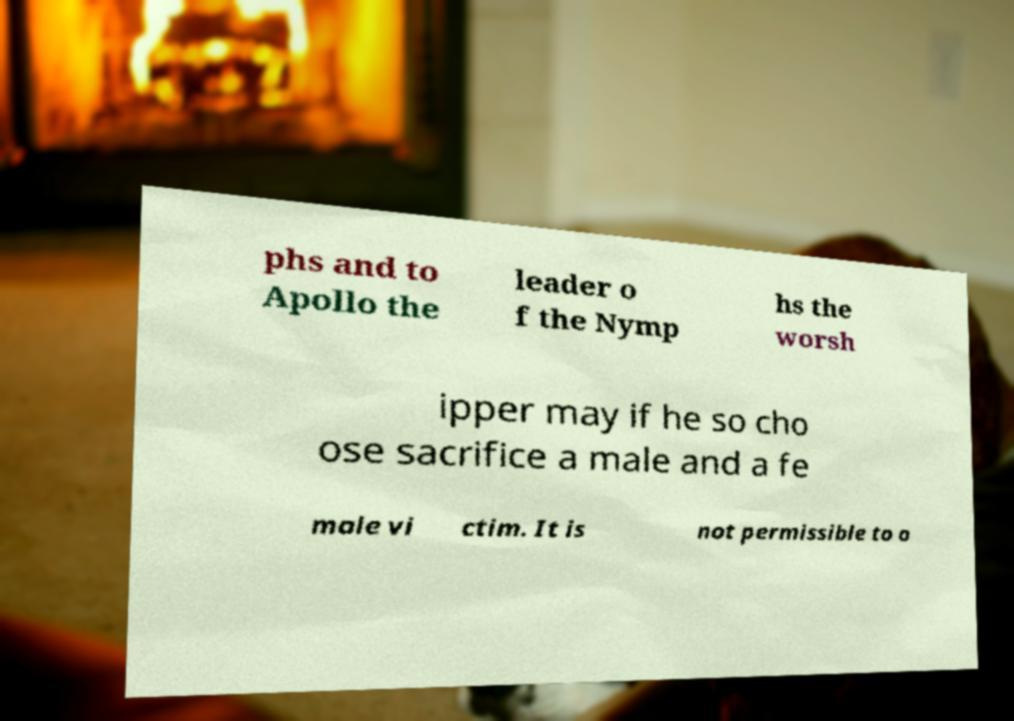Could you assist in decoding the text presented in this image and type it out clearly? phs and to Apollo the leader o f the Nymp hs the worsh ipper may if he so cho ose sacrifice a male and a fe male vi ctim. It is not permissible to o 